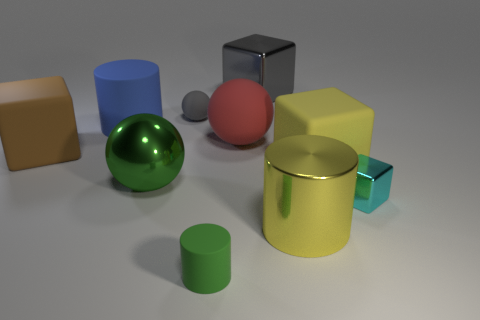Subtract all small cyan metal blocks. How many blocks are left? 3 Subtract all cylinders. How many objects are left? 7 Add 3 small things. How many small things exist? 6 Subtract all green cylinders. How many cylinders are left? 2 Subtract 0 gray cylinders. How many objects are left? 10 Subtract 3 spheres. How many spheres are left? 0 Subtract all brown cylinders. Subtract all brown cubes. How many cylinders are left? 3 Subtract all purple blocks. How many brown cylinders are left? 0 Subtract all yellow metal balls. Subtract all shiny cylinders. How many objects are left? 9 Add 6 red rubber balls. How many red rubber balls are left? 7 